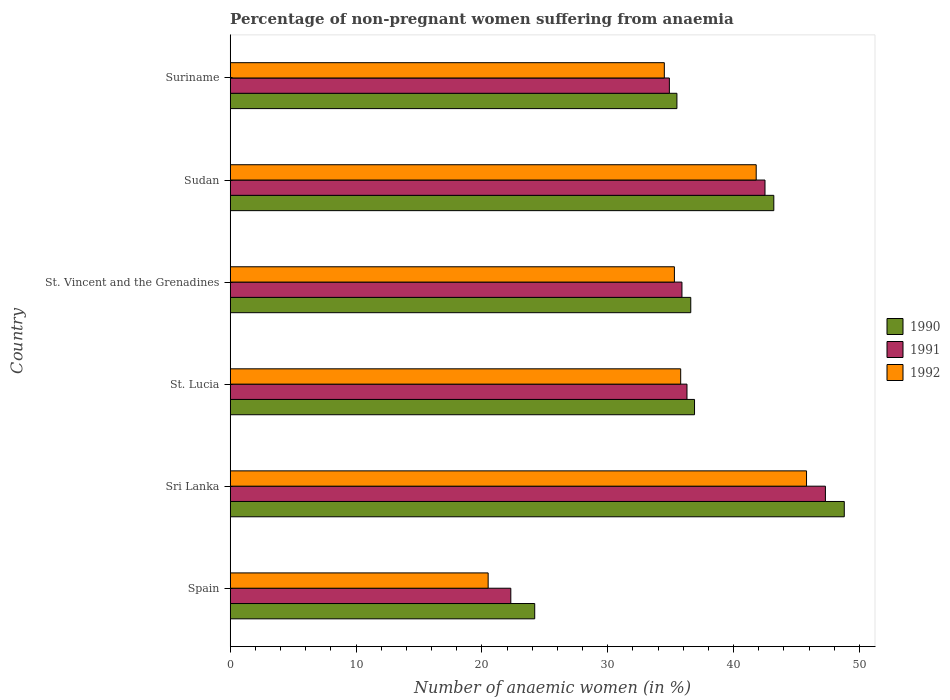How many different coloured bars are there?
Offer a terse response. 3. Are the number of bars per tick equal to the number of legend labels?
Offer a very short reply. Yes. Are the number of bars on each tick of the Y-axis equal?
Make the answer very short. Yes. How many bars are there on the 6th tick from the top?
Provide a short and direct response. 3. What is the label of the 6th group of bars from the top?
Your answer should be compact. Spain. In how many cases, is the number of bars for a given country not equal to the number of legend labels?
Provide a short and direct response. 0. What is the percentage of non-pregnant women suffering from anaemia in 1990 in St. Lucia?
Offer a terse response. 36.9. Across all countries, what is the maximum percentage of non-pregnant women suffering from anaemia in 1990?
Provide a succinct answer. 48.8. Across all countries, what is the minimum percentage of non-pregnant women suffering from anaemia in 1990?
Your response must be concise. 24.2. In which country was the percentage of non-pregnant women suffering from anaemia in 1992 maximum?
Your answer should be compact. Sri Lanka. In which country was the percentage of non-pregnant women suffering from anaemia in 1991 minimum?
Give a very brief answer. Spain. What is the total percentage of non-pregnant women suffering from anaemia in 1990 in the graph?
Provide a succinct answer. 225.2. What is the difference between the percentage of non-pregnant women suffering from anaemia in 1991 in Sudan and that in Suriname?
Keep it short and to the point. 7.6. What is the difference between the percentage of non-pregnant women suffering from anaemia in 1991 in Spain and the percentage of non-pregnant women suffering from anaemia in 1992 in Suriname?
Keep it short and to the point. -12.2. What is the average percentage of non-pregnant women suffering from anaemia in 1990 per country?
Make the answer very short. 37.53. What is the difference between the percentage of non-pregnant women suffering from anaemia in 1992 and percentage of non-pregnant women suffering from anaemia in 1991 in Sri Lanka?
Your answer should be very brief. -1.5. What is the ratio of the percentage of non-pregnant women suffering from anaemia in 1990 in St. Lucia to that in Sudan?
Your answer should be compact. 0.85. Is the percentage of non-pregnant women suffering from anaemia in 1991 in Sri Lanka less than that in Suriname?
Give a very brief answer. No. Is the difference between the percentage of non-pregnant women suffering from anaemia in 1992 in Sri Lanka and Sudan greater than the difference between the percentage of non-pregnant women suffering from anaemia in 1991 in Sri Lanka and Sudan?
Your response must be concise. No. What is the difference between the highest and the second highest percentage of non-pregnant women suffering from anaemia in 1991?
Provide a short and direct response. 4.8. What is the difference between the highest and the lowest percentage of non-pregnant women suffering from anaemia in 1990?
Keep it short and to the point. 24.6. In how many countries, is the percentage of non-pregnant women suffering from anaemia in 1992 greater than the average percentage of non-pregnant women suffering from anaemia in 1992 taken over all countries?
Offer a terse response. 3. What does the 1st bar from the bottom in Suriname represents?
Give a very brief answer. 1990. What is the difference between two consecutive major ticks on the X-axis?
Your response must be concise. 10. Are the values on the major ticks of X-axis written in scientific E-notation?
Keep it short and to the point. No. Does the graph contain any zero values?
Ensure brevity in your answer.  No. Does the graph contain grids?
Make the answer very short. No. How are the legend labels stacked?
Provide a succinct answer. Vertical. What is the title of the graph?
Ensure brevity in your answer.  Percentage of non-pregnant women suffering from anaemia. What is the label or title of the X-axis?
Your response must be concise. Number of anaemic women (in %). What is the label or title of the Y-axis?
Ensure brevity in your answer.  Country. What is the Number of anaemic women (in %) in 1990 in Spain?
Your response must be concise. 24.2. What is the Number of anaemic women (in %) of 1991 in Spain?
Ensure brevity in your answer.  22.3. What is the Number of anaemic women (in %) of 1992 in Spain?
Provide a short and direct response. 20.5. What is the Number of anaemic women (in %) of 1990 in Sri Lanka?
Your answer should be very brief. 48.8. What is the Number of anaemic women (in %) of 1991 in Sri Lanka?
Provide a short and direct response. 47.3. What is the Number of anaemic women (in %) of 1992 in Sri Lanka?
Keep it short and to the point. 45.8. What is the Number of anaemic women (in %) of 1990 in St. Lucia?
Your answer should be compact. 36.9. What is the Number of anaemic women (in %) in 1991 in St. Lucia?
Offer a very short reply. 36.3. What is the Number of anaemic women (in %) in 1992 in St. Lucia?
Your answer should be very brief. 35.8. What is the Number of anaemic women (in %) in 1990 in St. Vincent and the Grenadines?
Provide a succinct answer. 36.6. What is the Number of anaemic women (in %) of 1991 in St. Vincent and the Grenadines?
Keep it short and to the point. 35.9. What is the Number of anaemic women (in %) of 1992 in St. Vincent and the Grenadines?
Your response must be concise. 35.3. What is the Number of anaemic women (in %) of 1990 in Sudan?
Your answer should be compact. 43.2. What is the Number of anaemic women (in %) of 1991 in Sudan?
Your answer should be very brief. 42.5. What is the Number of anaemic women (in %) of 1992 in Sudan?
Your response must be concise. 41.8. What is the Number of anaemic women (in %) of 1990 in Suriname?
Provide a short and direct response. 35.5. What is the Number of anaemic women (in %) of 1991 in Suriname?
Offer a terse response. 34.9. What is the Number of anaemic women (in %) of 1992 in Suriname?
Your answer should be compact. 34.5. Across all countries, what is the maximum Number of anaemic women (in %) of 1990?
Give a very brief answer. 48.8. Across all countries, what is the maximum Number of anaemic women (in %) in 1991?
Ensure brevity in your answer.  47.3. Across all countries, what is the maximum Number of anaemic women (in %) in 1992?
Offer a very short reply. 45.8. Across all countries, what is the minimum Number of anaemic women (in %) of 1990?
Offer a terse response. 24.2. Across all countries, what is the minimum Number of anaemic women (in %) of 1991?
Provide a succinct answer. 22.3. What is the total Number of anaemic women (in %) in 1990 in the graph?
Offer a terse response. 225.2. What is the total Number of anaemic women (in %) in 1991 in the graph?
Your answer should be very brief. 219.2. What is the total Number of anaemic women (in %) of 1992 in the graph?
Offer a very short reply. 213.7. What is the difference between the Number of anaemic women (in %) in 1990 in Spain and that in Sri Lanka?
Your answer should be very brief. -24.6. What is the difference between the Number of anaemic women (in %) of 1992 in Spain and that in Sri Lanka?
Ensure brevity in your answer.  -25.3. What is the difference between the Number of anaemic women (in %) in 1991 in Spain and that in St. Lucia?
Provide a succinct answer. -14. What is the difference between the Number of anaemic women (in %) in 1992 in Spain and that in St. Lucia?
Ensure brevity in your answer.  -15.3. What is the difference between the Number of anaemic women (in %) in 1990 in Spain and that in St. Vincent and the Grenadines?
Provide a short and direct response. -12.4. What is the difference between the Number of anaemic women (in %) of 1992 in Spain and that in St. Vincent and the Grenadines?
Give a very brief answer. -14.8. What is the difference between the Number of anaemic women (in %) of 1990 in Spain and that in Sudan?
Offer a very short reply. -19. What is the difference between the Number of anaemic women (in %) of 1991 in Spain and that in Sudan?
Your answer should be very brief. -20.2. What is the difference between the Number of anaemic women (in %) of 1992 in Spain and that in Sudan?
Give a very brief answer. -21.3. What is the difference between the Number of anaemic women (in %) of 1992 in Spain and that in Suriname?
Your answer should be very brief. -14. What is the difference between the Number of anaemic women (in %) in 1991 in Sri Lanka and that in St. Lucia?
Your response must be concise. 11. What is the difference between the Number of anaemic women (in %) of 1992 in Sri Lanka and that in St. Lucia?
Keep it short and to the point. 10. What is the difference between the Number of anaemic women (in %) of 1991 in Sri Lanka and that in St. Vincent and the Grenadines?
Offer a terse response. 11.4. What is the difference between the Number of anaemic women (in %) of 1990 in Sri Lanka and that in Suriname?
Offer a terse response. 13.3. What is the difference between the Number of anaemic women (in %) of 1991 in Sri Lanka and that in Suriname?
Make the answer very short. 12.4. What is the difference between the Number of anaemic women (in %) in 1992 in St. Lucia and that in Sudan?
Make the answer very short. -6. What is the difference between the Number of anaemic women (in %) in 1990 in St. Lucia and that in Suriname?
Offer a very short reply. 1.4. What is the difference between the Number of anaemic women (in %) in 1992 in St. Lucia and that in Suriname?
Keep it short and to the point. 1.3. What is the difference between the Number of anaemic women (in %) of 1991 in St. Vincent and the Grenadines and that in Sudan?
Your answer should be compact. -6.6. What is the difference between the Number of anaemic women (in %) in 1992 in St. Vincent and the Grenadines and that in Sudan?
Offer a terse response. -6.5. What is the difference between the Number of anaemic women (in %) in 1990 in St. Vincent and the Grenadines and that in Suriname?
Provide a succinct answer. 1.1. What is the difference between the Number of anaemic women (in %) in 1991 in Sudan and that in Suriname?
Make the answer very short. 7.6. What is the difference between the Number of anaemic women (in %) in 1990 in Spain and the Number of anaemic women (in %) in 1991 in Sri Lanka?
Give a very brief answer. -23.1. What is the difference between the Number of anaemic women (in %) in 1990 in Spain and the Number of anaemic women (in %) in 1992 in Sri Lanka?
Provide a succinct answer. -21.6. What is the difference between the Number of anaemic women (in %) in 1991 in Spain and the Number of anaemic women (in %) in 1992 in Sri Lanka?
Offer a very short reply. -23.5. What is the difference between the Number of anaemic women (in %) in 1990 in Spain and the Number of anaemic women (in %) in 1991 in St. Lucia?
Provide a short and direct response. -12.1. What is the difference between the Number of anaemic women (in %) in 1990 in Spain and the Number of anaemic women (in %) in 1992 in St. Lucia?
Ensure brevity in your answer.  -11.6. What is the difference between the Number of anaemic women (in %) of 1991 in Spain and the Number of anaemic women (in %) of 1992 in St. Lucia?
Provide a succinct answer. -13.5. What is the difference between the Number of anaemic women (in %) of 1990 in Spain and the Number of anaemic women (in %) of 1992 in St. Vincent and the Grenadines?
Your response must be concise. -11.1. What is the difference between the Number of anaemic women (in %) of 1991 in Spain and the Number of anaemic women (in %) of 1992 in St. Vincent and the Grenadines?
Offer a very short reply. -13. What is the difference between the Number of anaemic women (in %) in 1990 in Spain and the Number of anaemic women (in %) in 1991 in Sudan?
Your response must be concise. -18.3. What is the difference between the Number of anaemic women (in %) in 1990 in Spain and the Number of anaemic women (in %) in 1992 in Sudan?
Ensure brevity in your answer.  -17.6. What is the difference between the Number of anaemic women (in %) in 1991 in Spain and the Number of anaemic women (in %) in 1992 in Sudan?
Keep it short and to the point. -19.5. What is the difference between the Number of anaemic women (in %) of 1991 in Spain and the Number of anaemic women (in %) of 1992 in Suriname?
Your answer should be compact. -12.2. What is the difference between the Number of anaemic women (in %) in 1990 in Sri Lanka and the Number of anaemic women (in %) in 1992 in St. Lucia?
Provide a short and direct response. 13. What is the difference between the Number of anaemic women (in %) of 1991 in Sri Lanka and the Number of anaemic women (in %) of 1992 in St. Lucia?
Offer a terse response. 11.5. What is the difference between the Number of anaemic women (in %) in 1990 in Sri Lanka and the Number of anaemic women (in %) in 1992 in St. Vincent and the Grenadines?
Provide a short and direct response. 13.5. What is the difference between the Number of anaemic women (in %) in 1991 in Sri Lanka and the Number of anaemic women (in %) in 1992 in St. Vincent and the Grenadines?
Your answer should be compact. 12. What is the difference between the Number of anaemic women (in %) of 1990 in Sri Lanka and the Number of anaemic women (in %) of 1991 in Sudan?
Offer a very short reply. 6.3. What is the difference between the Number of anaemic women (in %) of 1991 in Sri Lanka and the Number of anaemic women (in %) of 1992 in Suriname?
Offer a terse response. 12.8. What is the difference between the Number of anaemic women (in %) in 1990 in St. Lucia and the Number of anaemic women (in %) in 1992 in St. Vincent and the Grenadines?
Your answer should be very brief. 1.6. What is the difference between the Number of anaemic women (in %) in 1990 in St. Lucia and the Number of anaemic women (in %) in 1991 in Sudan?
Provide a succinct answer. -5.6. What is the difference between the Number of anaemic women (in %) of 1991 in St. Lucia and the Number of anaemic women (in %) of 1992 in Sudan?
Ensure brevity in your answer.  -5.5. What is the difference between the Number of anaemic women (in %) in 1990 in St. Lucia and the Number of anaemic women (in %) in 1991 in Suriname?
Offer a terse response. 2. What is the difference between the Number of anaemic women (in %) in 1990 in St. Lucia and the Number of anaemic women (in %) in 1992 in Suriname?
Provide a succinct answer. 2.4. What is the difference between the Number of anaemic women (in %) in 1991 in St. Lucia and the Number of anaemic women (in %) in 1992 in Suriname?
Keep it short and to the point. 1.8. What is the difference between the Number of anaemic women (in %) of 1990 in St. Vincent and the Grenadines and the Number of anaemic women (in %) of 1991 in Sudan?
Ensure brevity in your answer.  -5.9. What is the difference between the Number of anaemic women (in %) in 1991 in St. Vincent and the Grenadines and the Number of anaemic women (in %) in 1992 in Sudan?
Offer a very short reply. -5.9. What is the difference between the Number of anaemic women (in %) of 1990 in St. Vincent and the Grenadines and the Number of anaemic women (in %) of 1992 in Suriname?
Your answer should be compact. 2.1. What is the difference between the Number of anaemic women (in %) in 1990 in Sudan and the Number of anaemic women (in %) in 1991 in Suriname?
Provide a succinct answer. 8.3. What is the difference between the Number of anaemic women (in %) of 1990 in Sudan and the Number of anaemic women (in %) of 1992 in Suriname?
Your answer should be very brief. 8.7. What is the difference between the Number of anaemic women (in %) in 1991 in Sudan and the Number of anaemic women (in %) in 1992 in Suriname?
Your answer should be compact. 8. What is the average Number of anaemic women (in %) in 1990 per country?
Offer a very short reply. 37.53. What is the average Number of anaemic women (in %) of 1991 per country?
Ensure brevity in your answer.  36.53. What is the average Number of anaemic women (in %) in 1992 per country?
Give a very brief answer. 35.62. What is the difference between the Number of anaemic women (in %) of 1990 and Number of anaemic women (in %) of 1991 in Spain?
Your answer should be very brief. 1.9. What is the difference between the Number of anaemic women (in %) in 1990 and Number of anaemic women (in %) in 1992 in Spain?
Your answer should be very brief. 3.7. What is the difference between the Number of anaemic women (in %) in 1991 and Number of anaemic women (in %) in 1992 in Spain?
Keep it short and to the point. 1.8. What is the difference between the Number of anaemic women (in %) of 1990 and Number of anaemic women (in %) of 1991 in St. Lucia?
Keep it short and to the point. 0.6. What is the difference between the Number of anaemic women (in %) in 1991 and Number of anaemic women (in %) in 1992 in St. Lucia?
Your answer should be compact. 0.5. What is the difference between the Number of anaemic women (in %) of 1990 and Number of anaemic women (in %) of 1992 in St. Vincent and the Grenadines?
Make the answer very short. 1.3. What is the difference between the Number of anaemic women (in %) of 1991 and Number of anaemic women (in %) of 1992 in St. Vincent and the Grenadines?
Provide a succinct answer. 0.6. What is the difference between the Number of anaemic women (in %) of 1990 and Number of anaemic women (in %) of 1991 in Sudan?
Keep it short and to the point. 0.7. What is the difference between the Number of anaemic women (in %) in 1990 and Number of anaemic women (in %) in 1992 in Suriname?
Your response must be concise. 1. What is the difference between the Number of anaemic women (in %) in 1991 and Number of anaemic women (in %) in 1992 in Suriname?
Offer a terse response. 0.4. What is the ratio of the Number of anaemic women (in %) of 1990 in Spain to that in Sri Lanka?
Offer a very short reply. 0.5. What is the ratio of the Number of anaemic women (in %) of 1991 in Spain to that in Sri Lanka?
Ensure brevity in your answer.  0.47. What is the ratio of the Number of anaemic women (in %) of 1992 in Spain to that in Sri Lanka?
Make the answer very short. 0.45. What is the ratio of the Number of anaemic women (in %) of 1990 in Spain to that in St. Lucia?
Make the answer very short. 0.66. What is the ratio of the Number of anaemic women (in %) in 1991 in Spain to that in St. Lucia?
Provide a succinct answer. 0.61. What is the ratio of the Number of anaemic women (in %) in 1992 in Spain to that in St. Lucia?
Keep it short and to the point. 0.57. What is the ratio of the Number of anaemic women (in %) of 1990 in Spain to that in St. Vincent and the Grenadines?
Make the answer very short. 0.66. What is the ratio of the Number of anaemic women (in %) of 1991 in Spain to that in St. Vincent and the Grenadines?
Offer a very short reply. 0.62. What is the ratio of the Number of anaemic women (in %) of 1992 in Spain to that in St. Vincent and the Grenadines?
Offer a very short reply. 0.58. What is the ratio of the Number of anaemic women (in %) in 1990 in Spain to that in Sudan?
Offer a very short reply. 0.56. What is the ratio of the Number of anaemic women (in %) in 1991 in Spain to that in Sudan?
Your answer should be compact. 0.52. What is the ratio of the Number of anaemic women (in %) of 1992 in Spain to that in Sudan?
Offer a terse response. 0.49. What is the ratio of the Number of anaemic women (in %) in 1990 in Spain to that in Suriname?
Your answer should be compact. 0.68. What is the ratio of the Number of anaemic women (in %) in 1991 in Spain to that in Suriname?
Make the answer very short. 0.64. What is the ratio of the Number of anaemic women (in %) of 1992 in Spain to that in Suriname?
Offer a terse response. 0.59. What is the ratio of the Number of anaemic women (in %) in 1990 in Sri Lanka to that in St. Lucia?
Offer a very short reply. 1.32. What is the ratio of the Number of anaemic women (in %) in 1991 in Sri Lanka to that in St. Lucia?
Offer a terse response. 1.3. What is the ratio of the Number of anaemic women (in %) in 1992 in Sri Lanka to that in St. Lucia?
Provide a short and direct response. 1.28. What is the ratio of the Number of anaemic women (in %) in 1990 in Sri Lanka to that in St. Vincent and the Grenadines?
Provide a succinct answer. 1.33. What is the ratio of the Number of anaemic women (in %) in 1991 in Sri Lanka to that in St. Vincent and the Grenadines?
Provide a succinct answer. 1.32. What is the ratio of the Number of anaemic women (in %) of 1992 in Sri Lanka to that in St. Vincent and the Grenadines?
Offer a terse response. 1.3. What is the ratio of the Number of anaemic women (in %) in 1990 in Sri Lanka to that in Sudan?
Provide a short and direct response. 1.13. What is the ratio of the Number of anaemic women (in %) of 1991 in Sri Lanka to that in Sudan?
Offer a terse response. 1.11. What is the ratio of the Number of anaemic women (in %) of 1992 in Sri Lanka to that in Sudan?
Offer a very short reply. 1.1. What is the ratio of the Number of anaemic women (in %) of 1990 in Sri Lanka to that in Suriname?
Make the answer very short. 1.37. What is the ratio of the Number of anaemic women (in %) in 1991 in Sri Lanka to that in Suriname?
Offer a very short reply. 1.36. What is the ratio of the Number of anaemic women (in %) in 1992 in Sri Lanka to that in Suriname?
Your answer should be very brief. 1.33. What is the ratio of the Number of anaemic women (in %) of 1990 in St. Lucia to that in St. Vincent and the Grenadines?
Your response must be concise. 1.01. What is the ratio of the Number of anaemic women (in %) in 1991 in St. Lucia to that in St. Vincent and the Grenadines?
Keep it short and to the point. 1.01. What is the ratio of the Number of anaemic women (in %) of 1992 in St. Lucia to that in St. Vincent and the Grenadines?
Provide a short and direct response. 1.01. What is the ratio of the Number of anaemic women (in %) in 1990 in St. Lucia to that in Sudan?
Your answer should be very brief. 0.85. What is the ratio of the Number of anaemic women (in %) in 1991 in St. Lucia to that in Sudan?
Provide a short and direct response. 0.85. What is the ratio of the Number of anaemic women (in %) in 1992 in St. Lucia to that in Sudan?
Your answer should be very brief. 0.86. What is the ratio of the Number of anaemic women (in %) of 1990 in St. Lucia to that in Suriname?
Provide a succinct answer. 1.04. What is the ratio of the Number of anaemic women (in %) of 1991 in St. Lucia to that in Suriname?
Offer a very short reply. 1.04. What is the ratio of the Number of anaemic women (in %) in 1992 in St. Lucia to that in Suriname?
Your answer should be compact. 1.04. What is the ratio of the Number of anaemic women (in %) in 1990 in St. Vincent and the Grenadines to that in Sudan?
Your response must be concise. 0.85. What is the ratio of the Number of anaemic women (in %) in 1991 in St. Vincent and the Grenadines to that in Sudan?
Keep it short and to the point. 0.84. What is the ratio of the Number of anaemic women (in %) in 1992 in St. Vincent and the Grenadines to that in Sudan?
Provide a short and direct response. 0.84. What is the ratio of the Number of anaemic women (in %) in 1990 in St. Vincent and the Grenadines to that in Suriname?
Provide a succinct answer. 1.03. What is the ratio of the Number of anaemic women (in %) of 1991 in St. Vincent and the Grenadines to that in Suriname?
Your answer should be compact. 1.03. What is the ratio of the Number of anaemic women (in %) of 1992 in St. Vincent and the Grenadines to that in Suriname?
Your answer should be very brief. 1.02. What is the ratio of the Number of anaemic women (in %) of 1990 in Sudan to that in Suriname?
Your response must be concise. 1.22. What is the ratio of the Number of anaemic women (in %) of 1991 in Sudan to that in Suriname?
Make the answer very short. 1.22. What is the ratio of the Number of anaemic women (in %) of 1992 in Sudan to that in Suriname?
Offer a terse response. 1.21. What is the difference between the highest and the second highest Number of anaemic women (in %) in 1990?
Make the answer very short. 5.6. What is the difference between the highest and the second highest Number of anaemic women (in %) in 1991?
Keep it short and to the point. 4.8. What is the difference between the highest and the second highest Number of anaemic women (in %) in 1992?
Provide a succinct answer. 4. What is the difference between the highest and the lowest Number of anaemic women (in %) in 1990?
Make the answer very short. 24.6. What is the difference between the highest and the lowest Number of anaemic women (in %) in 1992?
Provide a succinct answer. 25.3. 